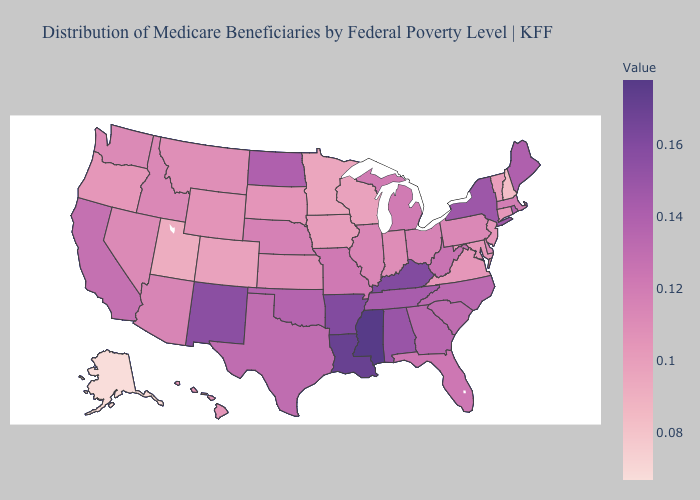Does Mississippi have the highest value in the South?
Give a very brief answer. Yes. Does Mississippi have the highest value in the USA?
Give a very brief answer. Yes. Does Michigan have a lower value than Oregon?
Be succinct. No. Does the map have missing data?
Give a very brief answer. No. Does Connecticut have the lowest value in the Northeast?
Be succinct. No. Among the states that border North Carolina , which have the highest value?
Concise answer only. Tennessee. 